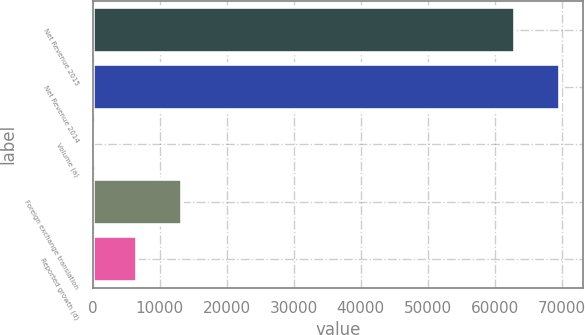<chart> <loc_0><loc_0><loc_500><loc_500><bar_chart><fcel>Net Revenue 2015<fcel>Net Revenue 2014<fcel>Volume (a)<fcel>Foreign exchange translation<fcel>Reported growth (d)<nl><fcel>63056<fcel>69724.2<fcel>0.5<fcel>13337<fcel>6668.75<nl></chart> 